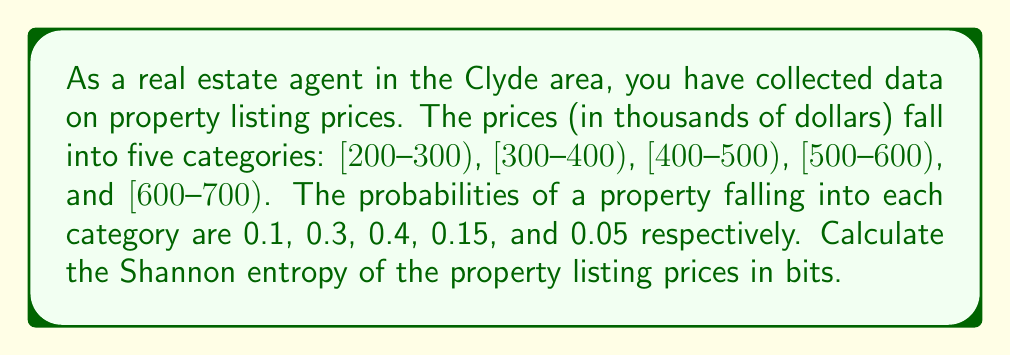Show me your answer to this math problem. To calculate the Shannon entropy, we'll use the formula:

$$H = -\sum_{i=1}^n p_i \log_2(p_i)$$

Where:
$H$ is the Shannon entropy
$p_i$ is the probability of each outcome
$n$ is the number of possible outcomes

Let's calculate each term:

1. For $[200-300)$: $p_1 = 0.1$
   $-0.1 \log_2(0.1) = 0.332$

2. For $[300-400)$: $p_2 = 0.3$
   $-0.3 \log_2(0.3) = 0.521$

3. For $[400-500)$: $p_3 = 0.4$
   $-0.4 \log_2(0.4) = 0.528$

4. For $[500-600)$: $p_4 = 0.15$
   $-0.15 \log_2(0.15) = 0.411$

5. For $[600-700)$: $p_5 = 0.05$
   $-0.05 \log_2(0.05) = 0.216$

Now, we sum all these terms:

$$H = 0.332 + 0.521 + 0.528 + 0.411 + 0.216 = 2.008$$

Therefore, the Shannon entropy of the property listing prices is approximately 2.008 bits.
Answer: The Shannon entropy of the property listing prices in the Clyde area is approximately 2.008 bits. 